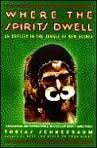Who wrote this book? The book 'Where the Spirits Dwell' was authored by Tobias Schneebaum, an explorer and writer known for his adventures in remote parts of the world. 